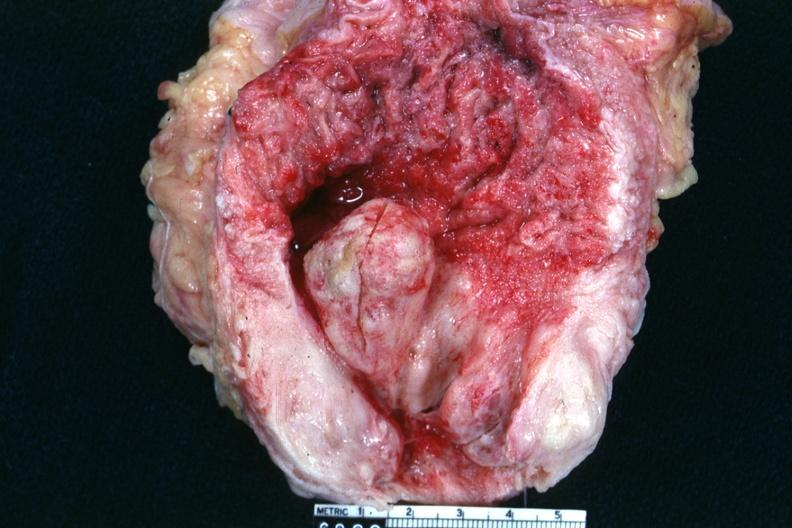does this image show opened bladder with very large prostate gland and high median lobe extending into floor of bladder inflamed bladder mucosa and very hypertrophied bladder?
Answer the question using a single word or phrase. Yes 